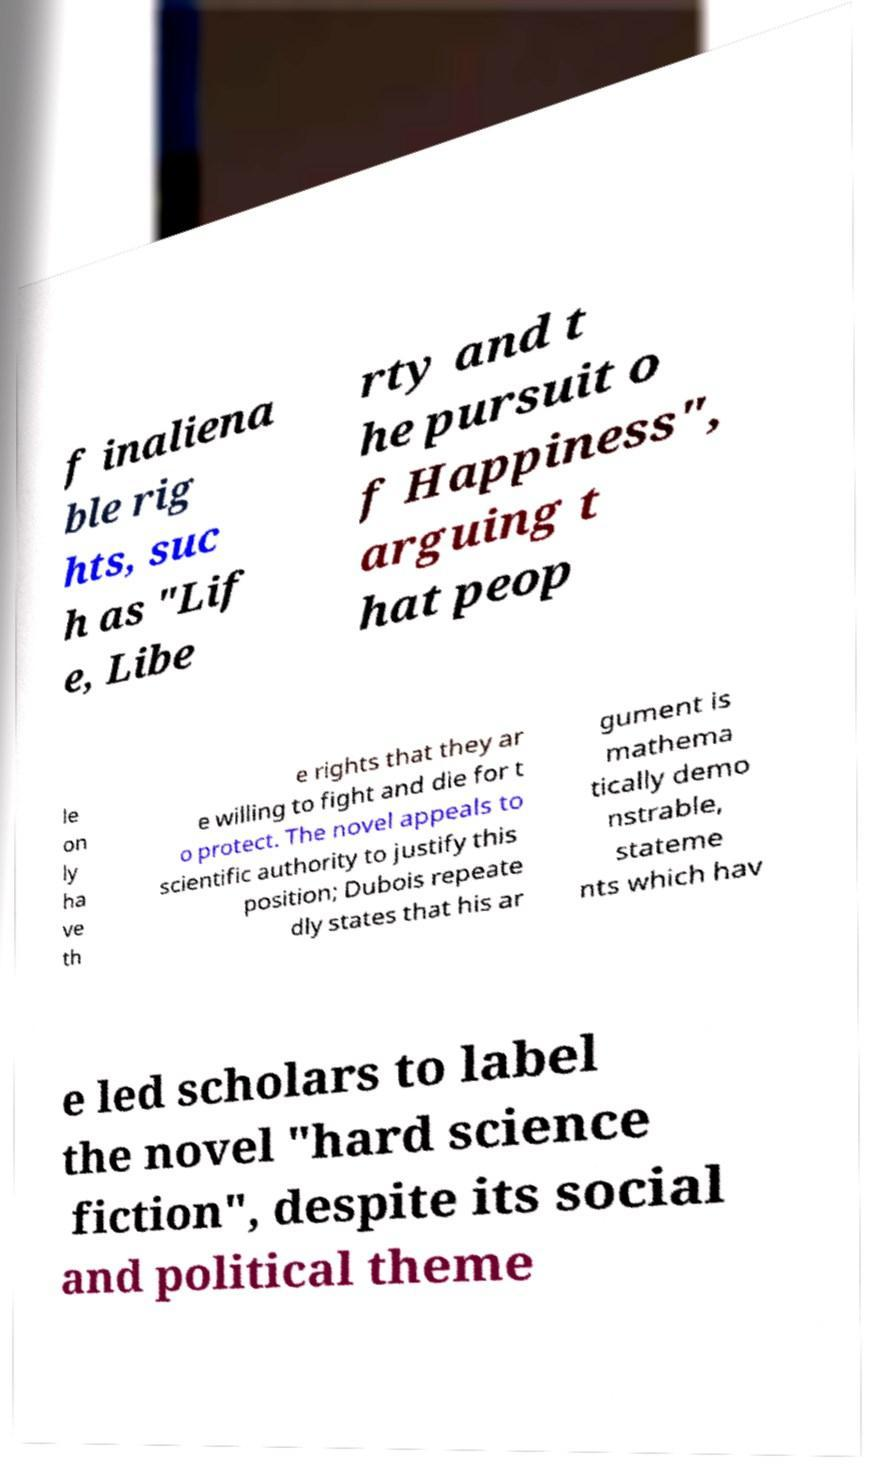Could you extract and type out the text from this image? f inaliena ble rig hts, suc h as "Lif e, Libe rty and t he pursuit o f Happiness", arguing t hat peop le on ly ha ve th e rights that they ar e willing to fight and die for t o protect. The novel appeals to scientific authority to justify this position; Dubois repeate dly states that his ar gument is mathema tically demo nstrable, stateme nts which hav e led scholars to label the novel "hard science fiction", despite its social and political theme 